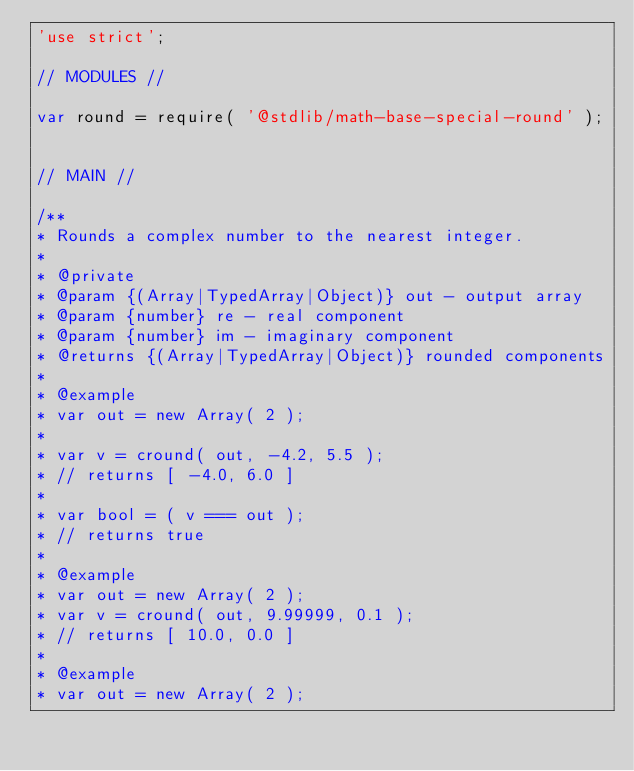Convert code to text. <code><loc_0><loc_0><loc_500><loc_500><_JavaScript_>'use strict';

// MODULES //

var round = require( '@stdlib/math-base-special-round' );


// MAIN //

/**
* Rounds a complex number to the nearest integer.
*
* @private
* @param {(Array|TypedArray|Object)} out - output array
* @param {number} re - real component
* @param {number} im - imaginary component
* @returns {(Array|TypedArray|Object)} rounded components
*
* @example
* var out = new Array( 2 );
*
* var v = cround( out, -4.2, 5.5 );
* // returns [ -4.0, 6.0 ]
*
* var bool = ( v === out );
* // returns true
*
* @example
* var out = new Array( 2 );
* var v = cround( out, 9.99999, 0.1 );
* // returns [ 10.0, 0.0 ]
*
* @example
* var out = new Array( 2 );</code> 